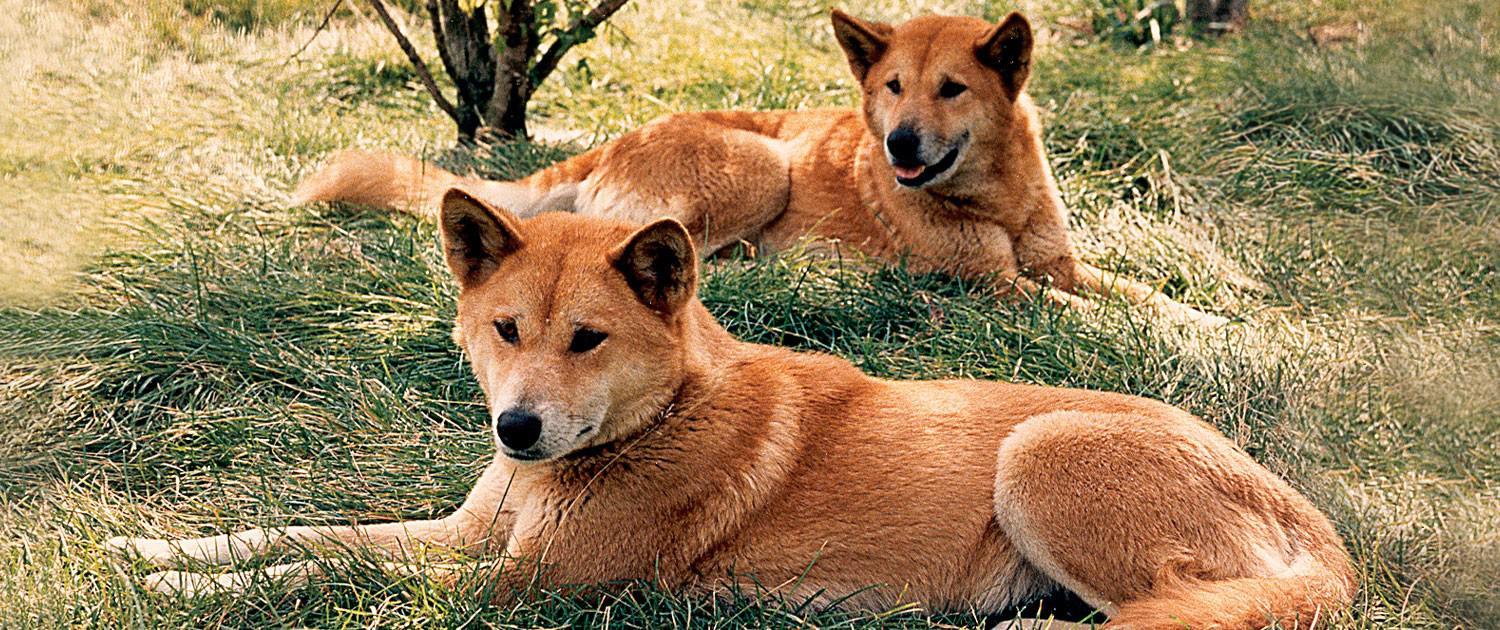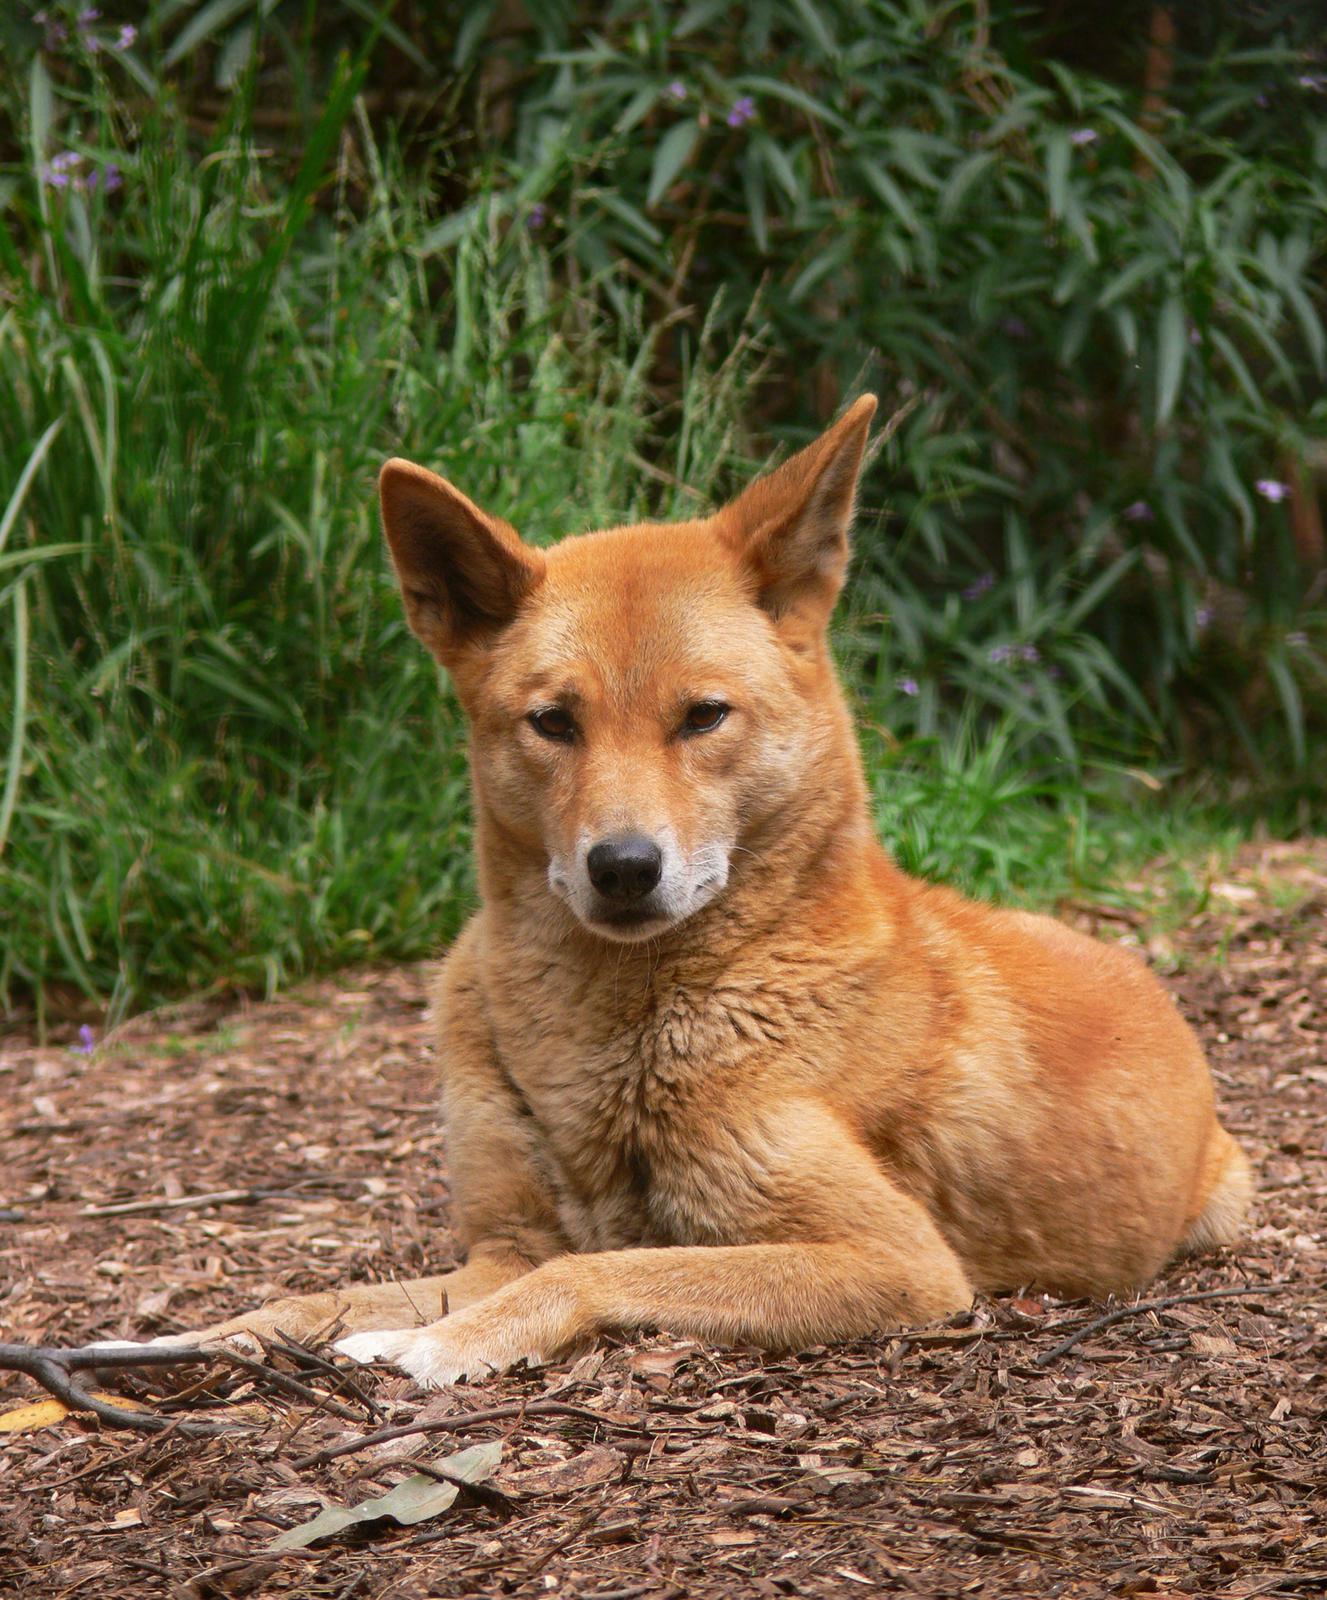The first image is the image on the left, the second image is the image on the right. For the images displayed, is the sentence "The wild dog in the image on the right is lying down outside." factually correct? Answer yes or no. Yes. The first image is the image on the left, the second image is the image on the right. Evaluate the accuracy of this statement regarding the images: "There are at most two dingoes.". Is it true? Answer yes or no. No. 